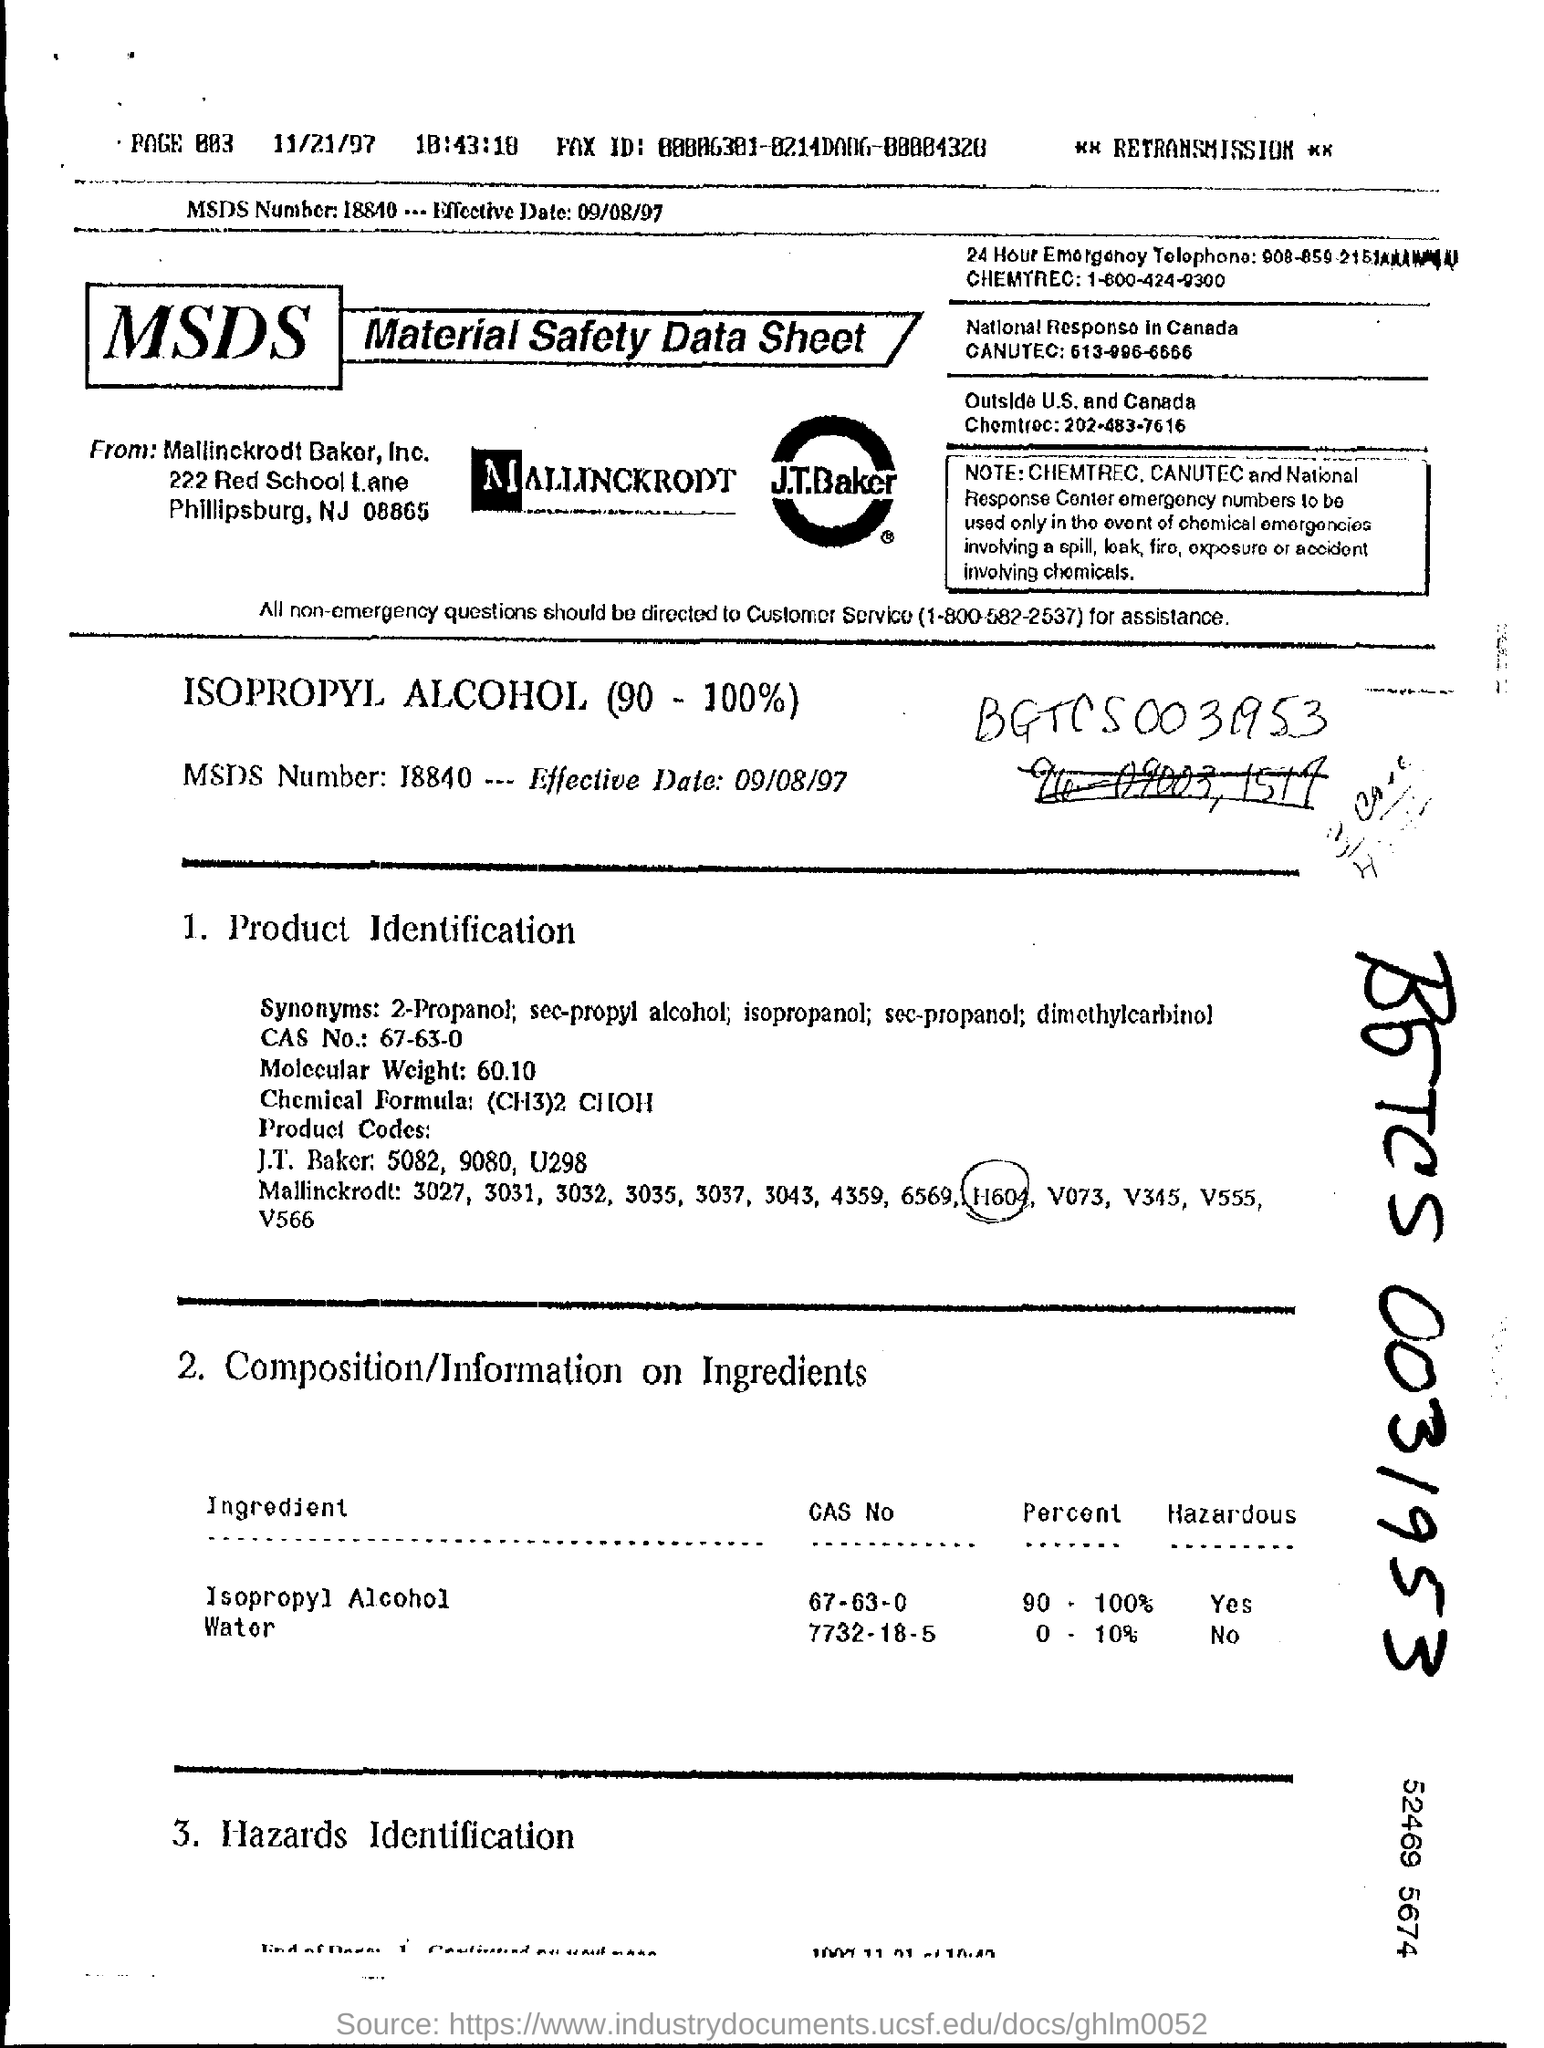What is the MSDS Number?
Your response must be concise. 18840. What is the Effective Date?
Your answer should be very brief. 09/08/97. What is the CAS NO. for Isopropyl Alcohol?
Make the answer very short. 67-63-0. What is the CAS NO. for Water?
Ensure brevity in your answer.  7732-18-5. What is the Percent for Isopropyl Alcohol?
Your answer should be compact. 90-100%. What is the Percent for Water?
Your response must be concise. 0 - 10%. What is the Molecular Weight?
Give a very brief answer. 60.10. What is the Chemical Formula?
Give a very brief answer. (CH3)2 CHOH. 